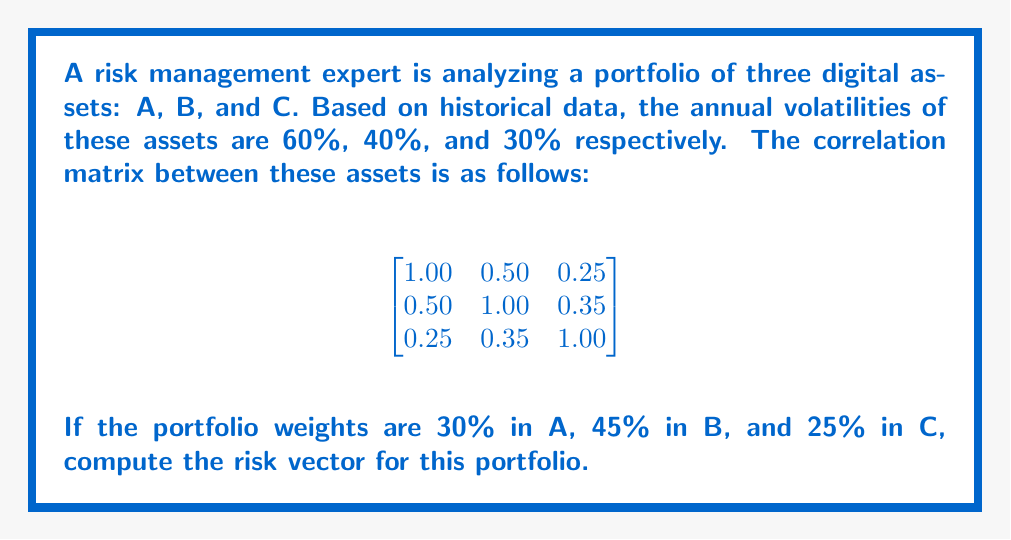Show me your answer to this math problem. To compute the risk vector for the portfolio, we'll follow these steps:

1) First, we need to create the volatility vector $\sigma$ and the weight vector $w$:

   $\sigma = \begin{bmatrix} 0.60 \\ 0.40 \\ 0.30 \end{bmatrix}$
   
   $w = \begin{bmatrix} 0.30 \\ 0.45 \\ 0.25 \end{bmatrix}$

2) Next, we'll create the correlation matrix $\rho$:

   $\rho = \begin{bmatrix}
   1.00 & 0.50 & 0.25 \\
   0.50 & 1.00 & 0.35 \\
   0.25 & 0.35 & 1.00
   \end{bmatrix}$

3) We need to convert the correlation matrix to a covariance matrix $\Sigma$. The formula is:
   $\Sigma_{ij} = \sigma_i \sigma_j \rho_{ij}$

   $\Sigma = \begin{bmatrix}
   0.60 * 0.60 * 1.00 & 0.60 * 0.40 * 0.50 & 0.60 * 0.30 * 0.25 \\
   0.60 * 0.40 * 0.50 & 0.40 * 0.40 * 1.00 & 0.40 * 0.30 * 0.35 \\
   0.60 * 0.30 * 0.25 & 0.40 * 0.30 * 0.35 & 0.30 * 0.30 * 1.00
   \end{bmatrix}$

   $\Sigma = \begin{bmatrix}
   0.3600 & 0.1200 & 0.0450 \\
   0.1200 & 0.1600 & 0.0420 \\
   0.0450 & 0.0420 & 0.0900
   \end{bmatrix}$

4) The risk vector is calculated as $\Sigma w$. Let's perform this matrix multiplication:

   $\Sigma w = \begin{bmatrix}
   0.3600 & 0.1200 & 0.0450 \\
   0.1200 & 0.1600 & 0.0420 \\
   0.0450 & 0.0420 & 0.0900
   \end{bmatrix} \begin{bmatrix} 0.30 \\ 0.45 \\ 0.25 \end{bmatrix}$

   $= \begin{bmatrix}
   0.3600 * 0.30 + 0.1200 * 0.45 + 0.0450 * 0.25 \\
   0.1200 * 0.30 + 0.1600 * 0.45 + 0.0420 * 0.25 \\
   0.0450 * 0.30 + 0.0420 * 0.45 + 0.0900 * 0.25
   \end{bmatrix}$

   $= \begin{bmatrix}
   0.1080 + 0.0540 + 0.01125 \\
   0.0360 + 0.0720 + 0.01050 \\
   0.0135 + 0.0189 + 0.02250
   \end{bmatrix}$

   $= \begin{bmatrix}
   0.17325 \\
   0.11850 \\
   0.05490
   \end{bmatrix}$
Answer: $$\begin{bmatrix} 0.17325 \\ 0.11850 \\ 0.05490 \end{bmatrix}$$ 